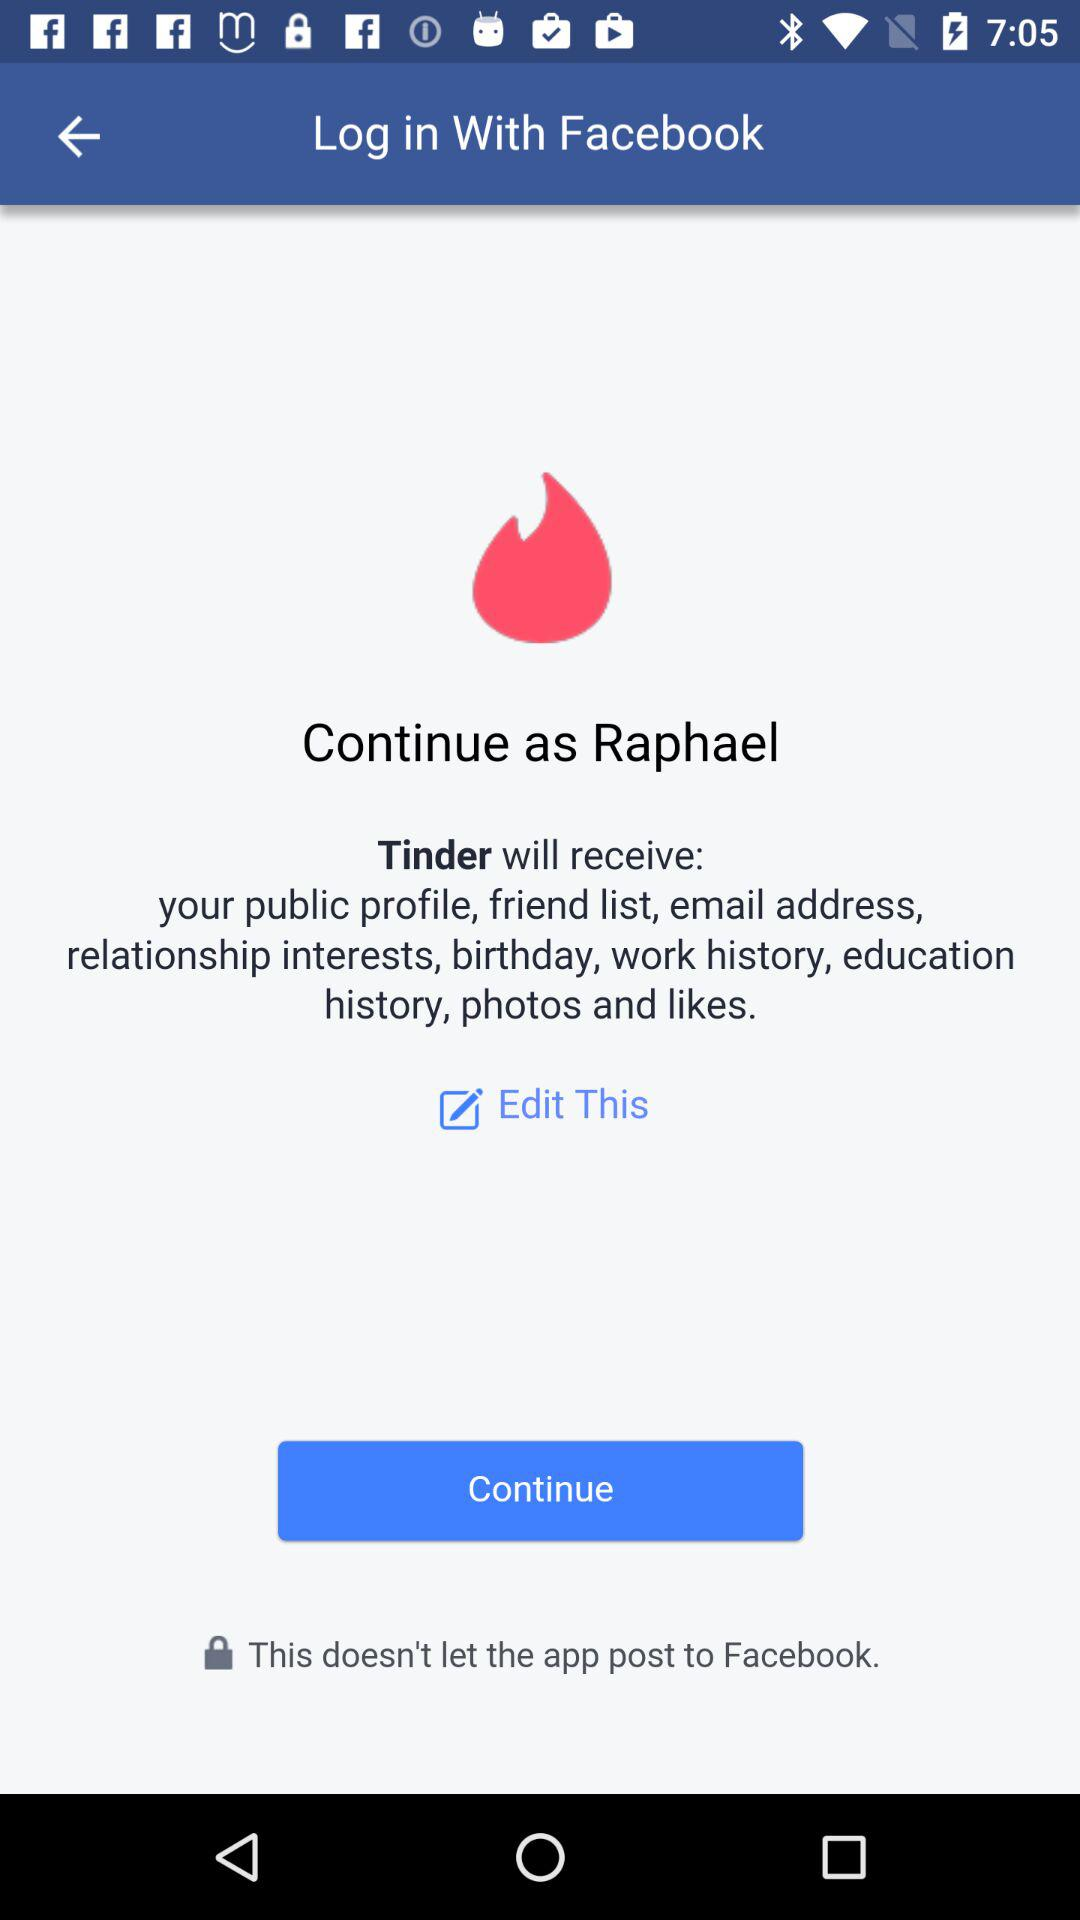What application can be used to log in? The application that can be used to log in is "Facebook". 